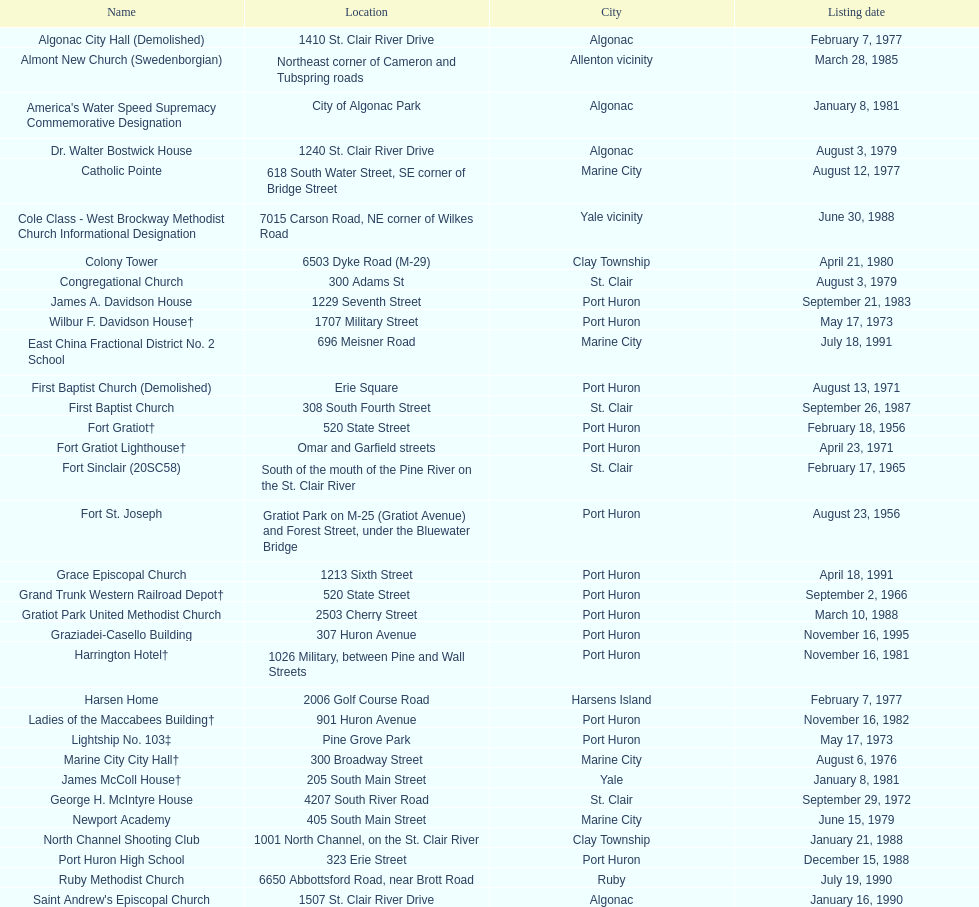In which city can you find fort gratiot lighthouse and fort st. joseph? Port Huron. Would you be able to parse every entry in this table? {'header': ['Name', 'Location', 'City', 'Listing date'], 'rows': [['Algonac City Hall (Demolished)', '1410 St. Clair River Drive', 'Algonac', 'February 7, 1977'], ['Almont New Church (Swedenborgian)', 'Northeast corner of Cameron and Tubspring roads', 'Allenton vicinity', 'March 28, 1985'], ["America's Water Speed Supremacy Commemorative Designation", 'City of Algonac Park', 'Algonac', 'January 8, 1981'], ['Dr. Walter Bostwick House', '1240 St. Clair River Drive', 'Algonac', 'August 3, 1979'], ['Catholic Pointe', '618 South Water Street, SE corner of Bridge Street', 'Marine City', 'August 12, 1977'], ['Cole Class - West Brockway Methodist Church Informational Designation', '7015 Carson Road, NE corner of Wilkes Road', 'Yale vicinity', 'June 30, 1988'], ['Colony Tower', '6503 Dyke Road (M-29)', 'Clay Township', 'April 21, 1980'], ['Congregational Church', '300 Adams St', 'St. Clair', 'August 3, 1979'], ['James A. Davidson House', '1229 Seventh Street', 'Port Huron', 'September 21, 1983'], ['Wilbur F. Davidson House†', '1707 Military Street', 'Port Huron', 'May 17, 1973'], ['East China Fractional District No. 2 School', '696 Meisner Road', 'Marine City', 'July 18, 1991'], ['First Baptist Church (Demolished)', 'Erie Square', 'Port Huron', 'August 13, 1971'], ['First Baptist Church', '308 South Fourth Street', 'St. Clair', 'September 26, 1987'], ['Fort Gratiot†', '520 State Street', 'Port Huron', 'February 18, 1956'], ['Fort Gratiot Lighthouse†', 'Omar and Garfield streets', 'Port Huron', 'April 23, 1971'], ['Fort Sinclair (20SC58)', 'South of the mouth of the Pine River on the St. Clair River', 'St. Clair', 'February 17, 1965'], ['Fort St. Joseph', 'Gratiot Park on M-25 (Gratiot Avenue) and Forest Street, under the Bluewater Bridge', 'Port Huron', 'August 23, 1956'], ['Grace Episcopal Church', '1213 Sixth Street', 'Port Huron', 'April 18, 1991'], ['Grand Trunk Western Railroad Depot†', '520 State Street', 'Port Huron', 'September 2, 1966'], ['Gratiot Park United Methodist Church', '2503 Cherry Street', 'Port Huron', 'March 10, 1988'], ['Graziadei-Casello Building', '307 Huron Avenue', 'Port Huron', 'November 16, 1995'], ['Harrington Hotel†', '1026 Military, between Pine and Wall Streets', 'Port Huron', 'November 16, 1981'], ['Harsen Home', '2006 Golf Course Road', 'Harsens Island', 'February 7, 1977'], ['Ladies of the Maccabees Building†', '901 Huron Avenue', 'Port Huron', 'November 16, 1982'], ['Lightship No. 103‡', 'Pine Grove Park', 'Port Huron', 'May 17, 1973'], ['Marine City City Hall†', '300 Broadway Street', 'Marine City', 'August 6, 1976'], ['James McColl House†', '205 South Main Street', 'Yale', 'January 8, 1981'], ['George H. McIntyre House', '4207 South River Road', 'St. Clair', 'September 29, 1972'], ['Newport Academy', '405 South Main Street', 'Marine City', 'June 15, 1979'], ['North Channel Shooting Club', '1001 North Channel, on the St. Clair River', 'Clay Township', 'January 21, 1988'], ['Port Huron High School', '323 Erie Street', 'Port Huron', 'December 15, 1988'], ['Ruby Methodist Church', '6650 Abbottsford Road, near Brott Road', 'Ruby', 'July 19, 1990'], ["Saint Andrew's Episcopal Church", '1507 St. Clair River Drive', 'Algonac', 'January 16, 1990'], ['Saint Clair Inn†', '500 Riverside', 'St. Clair', 'October 20, 1994'], ['Saint Clair River Informational Designation', '2 Miles north of Algonac on M-29', 'Algonac', 'January 19, 1957'], ['St. Clair River Tunnel‡', 'Between Johnstone & Beard, near 10th Street (portal site)', 'Port Huron', 'August 23, 1956'], ['Saint Johannes Evangelische Kirche', '710 Pine Street, at Seventh Street', 'Port Huron', 'March 19, 1980'], ["Saint Mary's Catholic Church and Rectory", '415 North Sixth Street, between Vine and Orchard streets', 'St. Clair', 'September 25, 1985'], ['Jefferson Sheldon House', '807 Prospect Place', 'Port Huron', 'April 19, 1990'], ['Trinity Evangelical Lutheran Church', '1517 Tenth Street', 'Port Huron', 'August 29, 1996'], ['Wales Township Hall', '1372 Wales Center', 'Wales Township', 'July 18, 1996'], ['Ward-Holland House†', '433 North Main Street', 'Marine City', 'May 5, 1964'], ['E. C. Williams House', '2511 Tenth Avenue, between Hancock and Church streets', 'Port Huron', 'November 18, 1993'], ['C. H. Wills & Company', 'Chrysler Plant, 840 Huron Avenue', 'Marysville', 'June 23, 1983'], ["Woman's Benefit Association Building", '1338 Military Street', 'Port Huron', 'December 15, 1988']]} 